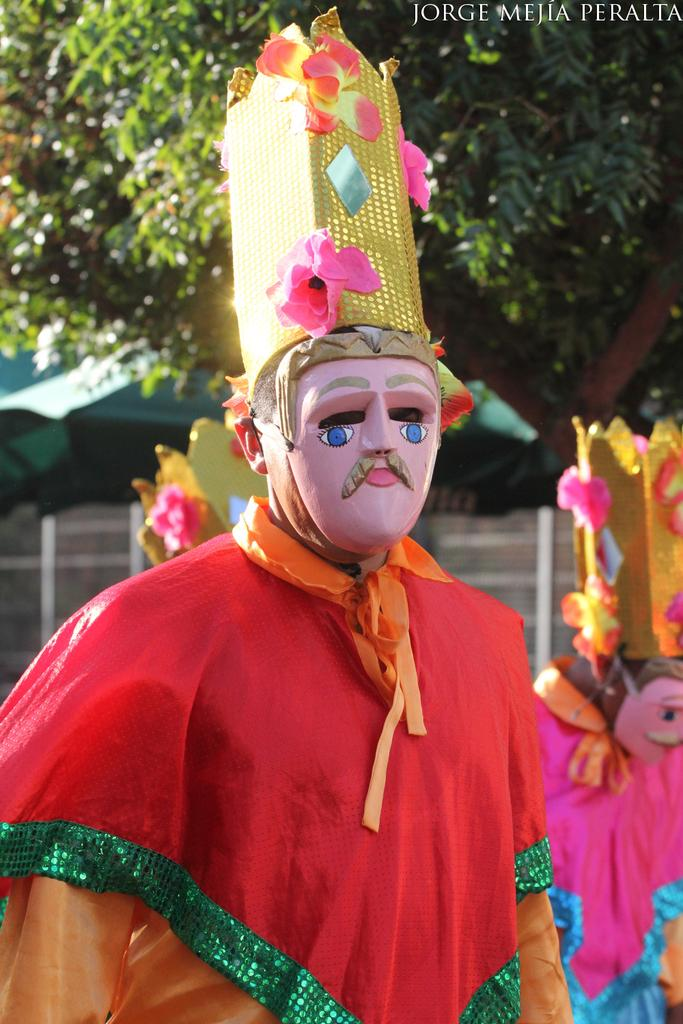How many people are in the image? There are two persons standing in the image. What are the persons wearing? The persons are wearing costumes and masks. What can be seen in the background of the image? There is a tree and a shed in the background of the image. Is there any text in the image? Yes, there is some text in the top right corner of the image. Can you see a throne in the image? No, there is no throne present in the image. Is there a giraffe in the image? No, there is no giraffe present in the image. 